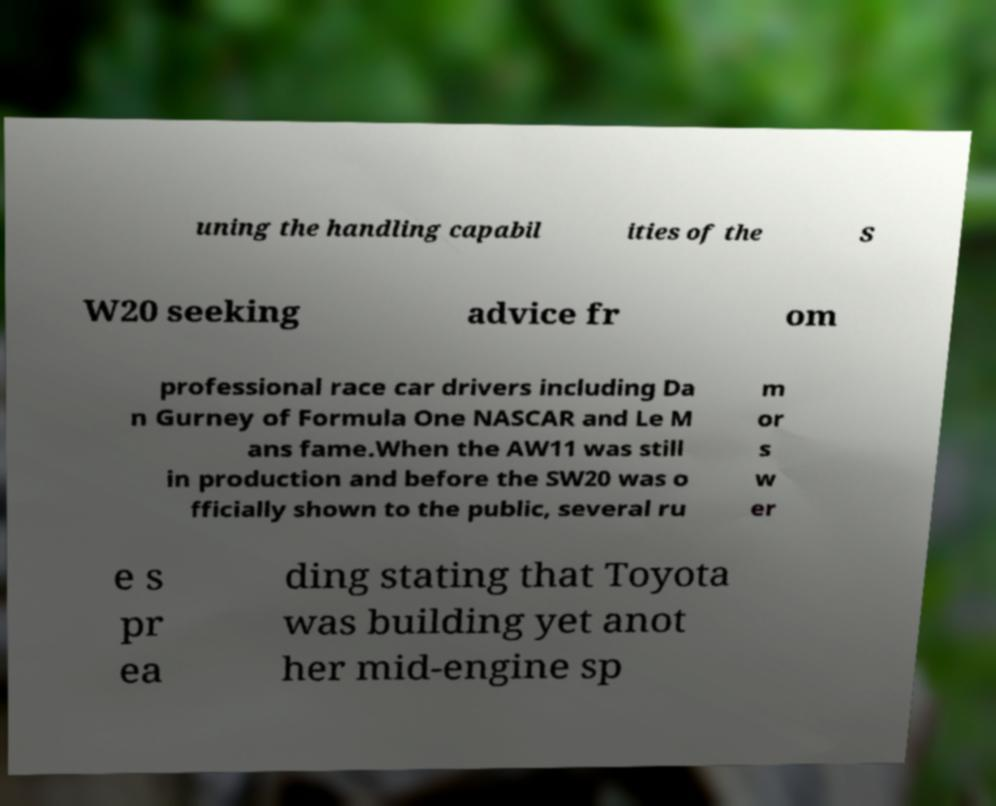Can you read and provide the text displayed in the image?This photo seems to have some interesting text. Can you extract and type it out for me? uning the handling capabil ities of the S W20 seeking advice fr om professional race car drivers including Da n Gurney of Formula One NASCAR and Le M ans fame.When the AW11 was still in production and before the SW20 was o fficially shown to the public, several ru m or s w er e s pr ea ding stating that Toyota was building yet anot her mid-engine sp 